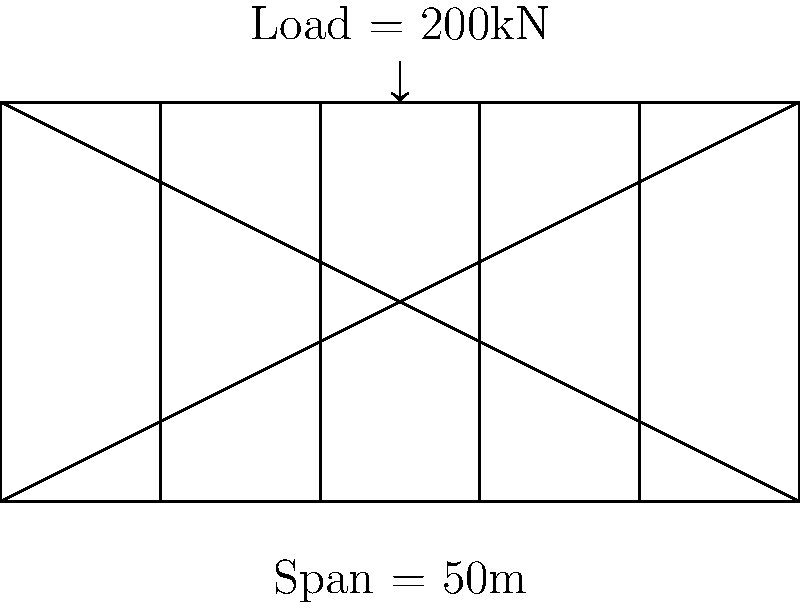As a travel agent promoting local literature, you've been asked to organize a book fair on a newly constructed truss bridge. The bridge engineer has provided you with the following information: the bridge has a span of 50m and needs to support a distributed load of 200kN for the book fair setup. What is the maximum bending moment (in kNm) at the center of this simply supported truss bridge? To calculate the maximum bending moment at the center of a simply supported bridge with a uniformly distributed load, we can follow these steps:

1. Identify the given information:
   - Span (L) = 50m
   - Total load (W) = 200kN

2. Calculate the distributed load (w):
   w = W / L = 200kN / 50m = 4 kN/m

3. For a simply supported beam with a uniformly distributed load, the maximum bending moment occurs at the center and is given by the formula:
   
   $M_{max} = \frac{wL^2}{8}$

4. Substitute the values into the formula:
   $M_{max} = \frac{4 \text{ kN/m} \times (50\text{ m})^2}{8}$

5. Calculate:
   $M_{max} = \frac{4 \times 2500}{8} = 1250 \text{ kNm}$

Therefore, the maximum bending moment at the center of the truss bridge is 1250 kNm.
Answer: 1250 kNm 